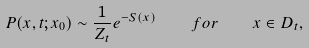Convert formula to latex. <formula><loc_0><loc_0><loc_500><loc_500>P ( x , t ; x _ { 0 } ) \sim \frac { 1 } { Z _ { t } } e ^ { - S ( x ) } \quad f o r \quad x \in D _ { t } ,</formula> 